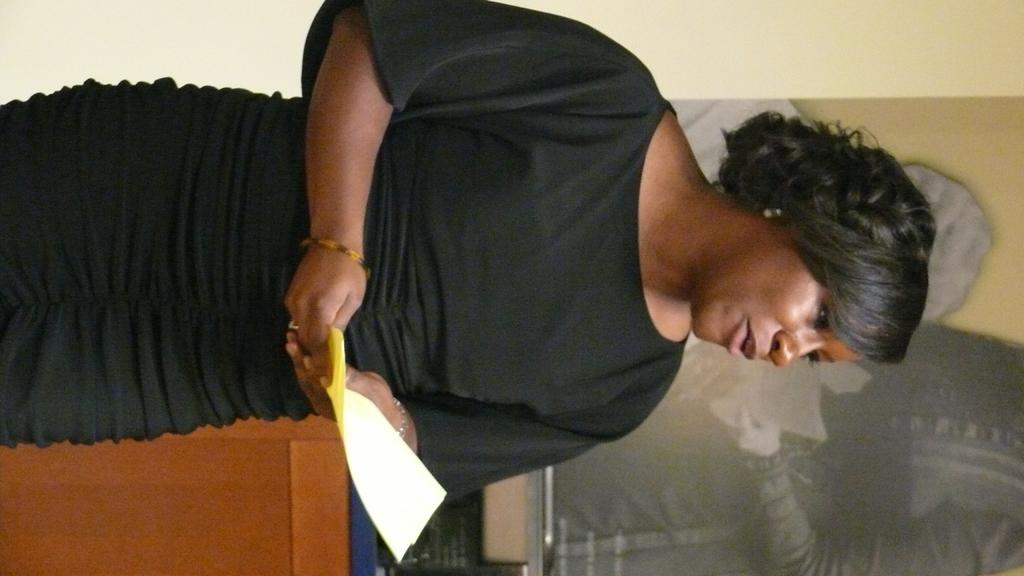Who is the main subject in the image? There is a woman in the image. What is the woman holding in her hands? The woman is holding papers in her hands. What can be seen in the background of the image? There is a poster on the wall in the background of the image. How does the woman's laughter affect the temperature in the room? The image does not show the woman laughing, and there is no indication of the temperature in the room. 